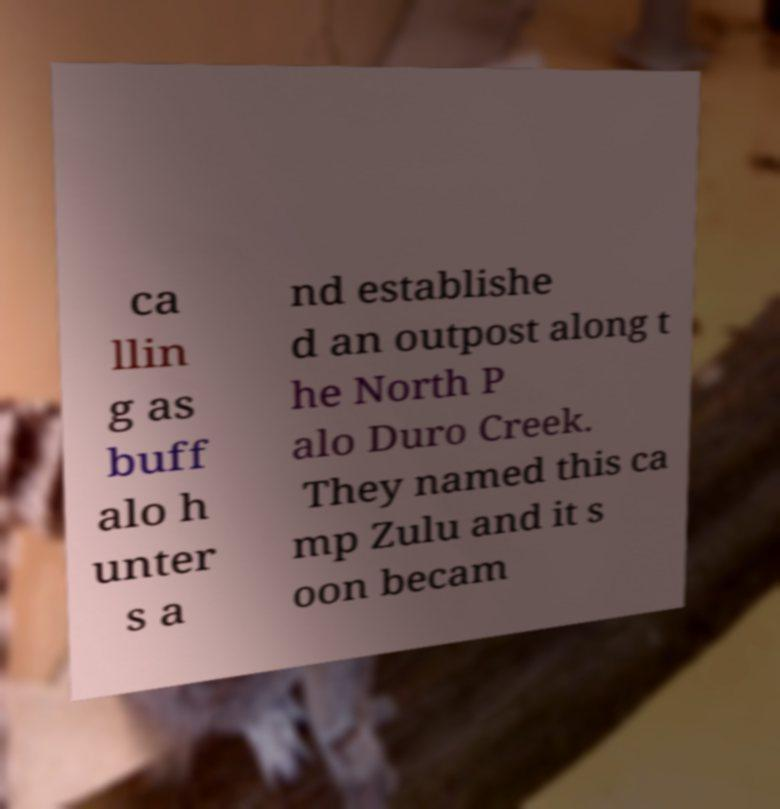Can you accurately transcribe the text from the provided image for me? ca llin g as buff alo h unter s a nd establishe d an outpost along t he North P alo Duro Creek. They named this ca mp Zulu and it s oon becam 